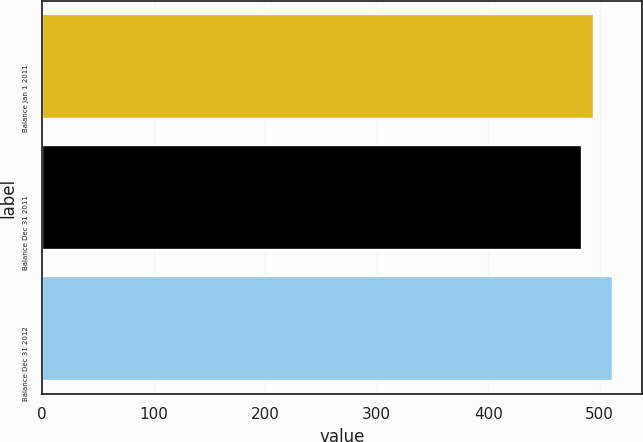<chart> <loc_0><loc_0><loc_500><loc_500><bar_chart><fcel>Balance Jan 1 2011<fcel>Balance Dec 31 2011<fcel>Balance Dec 31 2012<nl><fcel>495<fcel>484<fcel>512<nl></chart> 